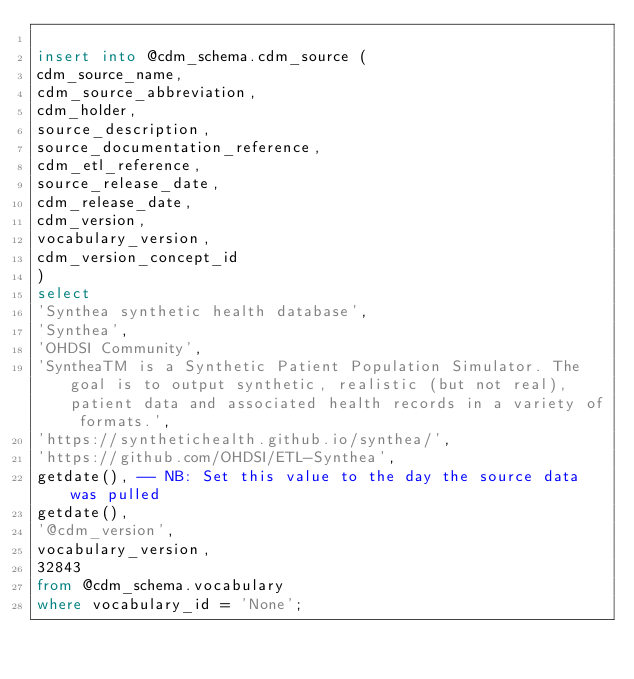Convert code to text. <code><loc_0><loc_0><loc_500><loc_500><_SQL_>
insert into @cdm_schema.cdm_source (
cdm_source_name,
cdm_source_abbreviation,
cdm_holder,
source_description,
source_documentation_reference,
cdm_etl_reference,
source_release_date,
cdm_release_date,
cdm_version,
vocabulary_version,
cdm_version_concept_id
) 
select
'Synthea synthetic health database',
'Synthea',
'OHDSI Community',
'SyntheaTM is a Synthetic Patient Population Simulator. The goal is to output synthetic, realistic (but not real), patient data and associated health records in a variety of formats.',
'https://synthetichealth.github.io/synthea/',
'https://github.com/OHDSI/ETL-Synthea',
getdate(), -- NB: Set this value to the day the source data was pulled
getdate(), 
'@cdm_version',
vocabulary_version,
32843
from @cdm_schema.vocabulary 
where vocabulary_id = 'None';
</code> 